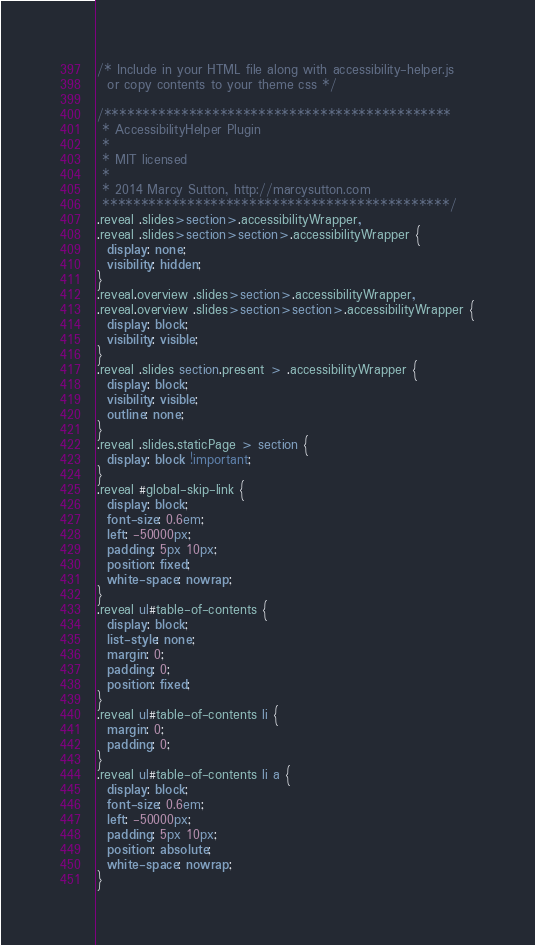Convert code to text. <code><loc_0><loc_0><loc_500><loc_500><_CSS_>
/* Include in your HTML file along with accessibility-helper.js
  or copy contents to your theme css */

/*********************************************
 * AccessibilityHelper Plugin
 *
 * MIT licensed
 *
 * 2014 Marcy Sutton, http://marcysutton.com
 *********************************************/
.reveal .slides>section>.accessibilityWrapper,
.reveal .slides>section>section>.accessibilityWrapper {
  display: none;
  visibility: hidden;
}
.reveal.overview .slides>section>.accessibilityWrapper,
.reveal.overview .slides>section>section>.accessibilityWrapper {
  display: block;
  visibility: visible;
}
.reveal .slides section.present > .accessibilityWrapper {
  display: block;
  visibility: visible;
  outline: none;
}
.reveal .slides.staticPage > section {
  display: block !important;
}
.reveal #global-skip-link {
  display: block;
  font-size: 0.6em;
  left: -50000px;
  padding: 5px 10px;
  position: fixed;
  white-space: nowrap;
}
.reveal ul#table-of-contents {
  display: block;
  list-style: none;
  margin: 0;
  padding: 0;
  position: fixed;
}
.reveal ul#table-of-contents li {
  margin: 0;
  padding: 0;
}
.reveal ul#table-of-contents li a {
  display: block;
  font-size: 0.6em;
  left: -50000px;
  padding: 5px 10px;
  position: absolute;
  white-space: nowrap;
}</code> 